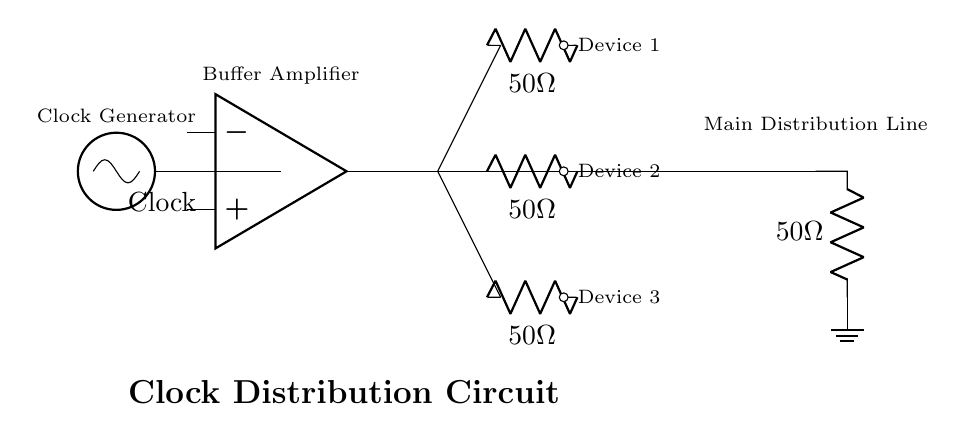What is the main component used to generate the clock signal? The main component is the oscillator labeled "Clock" which initiates the clock signal for the circuit. Its role is to produce oscillations that will be distributed to the devices.
Answer: Clock What is the value of the termination resistor? The circuit has a termination resistor connected at the end of the main distribution line, and it is labeled as fifty ohms. This resistor helps to minimize reflections in the circuit.
Answer: 50 Ohm How many devices are connected to the distribution line? There are three devices connected, each represented by an open circle with sequential numbering (1, 2, and 3) to indicate their positions along the branch of the distribution line.
Answer: 3 What type of amplifier is used in this circuit? A buffer amplifier is used, which is generally utilized in circuits to isolate stages and reduce loading effects, thus maintaining signal integrity during distribution.
Answer: Buffer Amplifier What is the purpose of the buffer amplifier in this circuit? The buffer amplifier's purpose is to strengthen the clock signal coming from the oscillator before it is distributed to other components. This ensures that the signal remains strong and reliable for synchronization of all connected devices.
Answer: Signal strengthening 